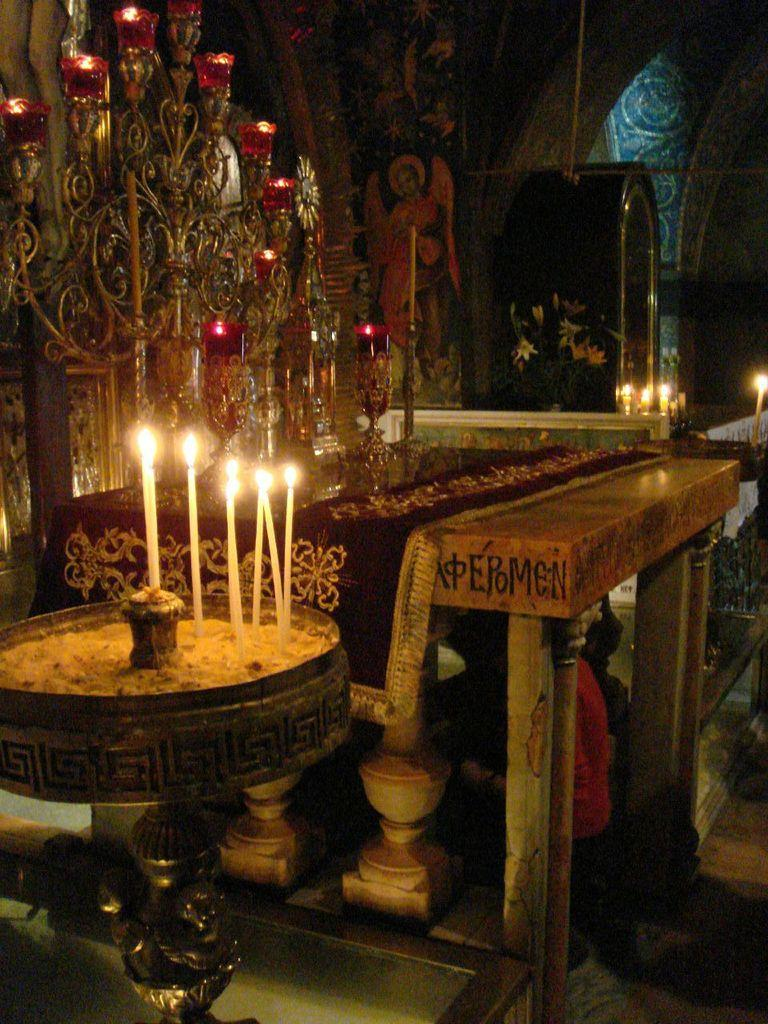What objects are on stands in the image? There are candles on stands in the image. What is covering the table in the image? There is a cloth on the table in the image. What can be seen on the wall in the background of the image? There is a painting on the wall in the background of the image. Are there any candles visible in the background of the image? Yes, there are candles visible in the background of the image. What else can be seen in the background of the image? There are objects present in the background of the image. What type of stone is used to build the vacation home in the image? There is no vacation home present in the image, and therefore no stone can be identified. What process is being used to create the candles in the image? The image does not show the process of creating the candles; it only shows the candles on stands and in the background. 